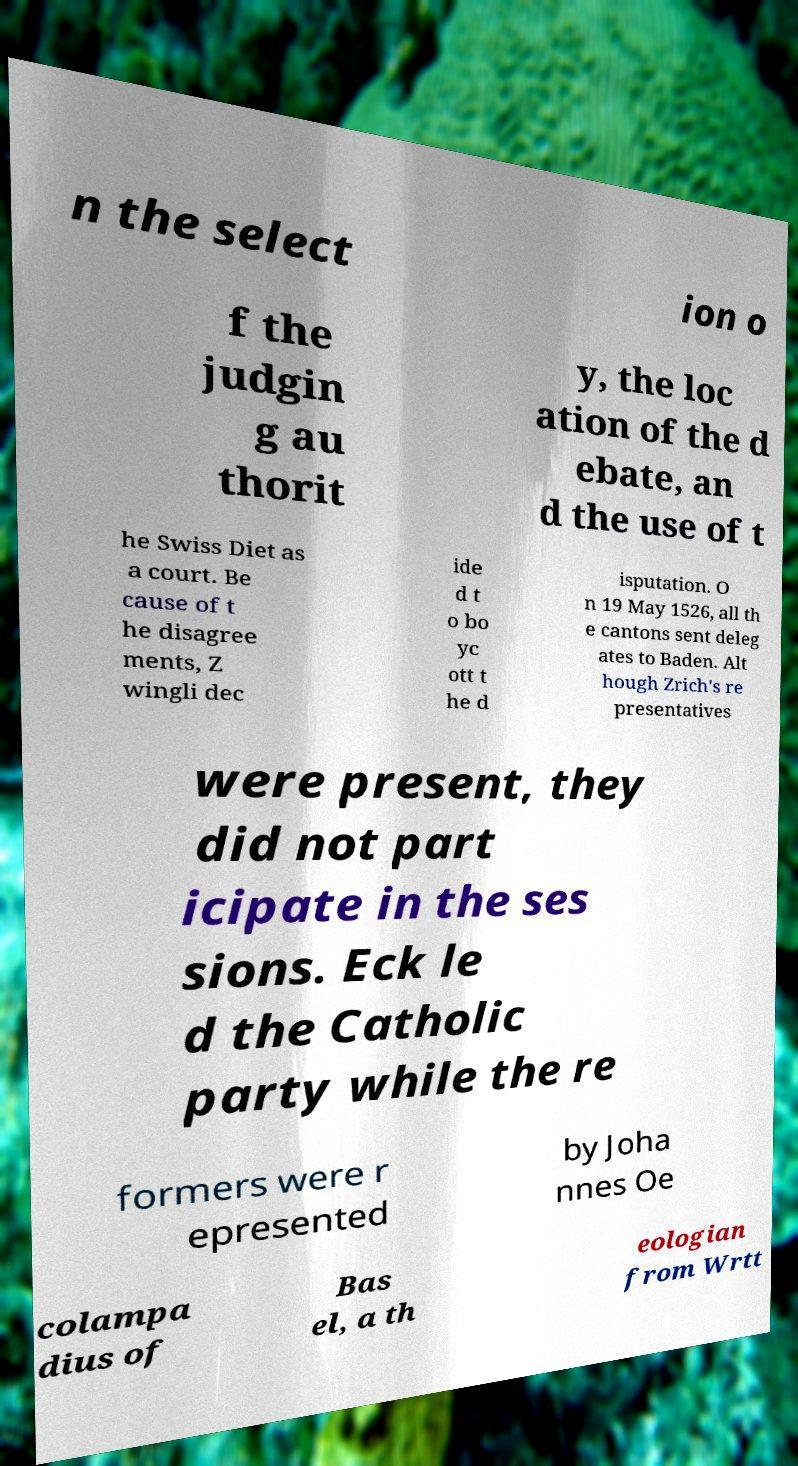There's text embedded in this image that I need extracted. Can you transcribe it verbatim? n the select ion o f the judgin g au thorit y, the loc ation of the d ebate, an d the use of t he Swiss Diet as a court. Be cause of t he disagree ments, Z wingli dec ide d t o bo yc ott t he d isputation. O n 19 May 1526, all th e cantons sent deleg ates to Baden. Alt hough Zrich's re presentatives were present, they did not part icipate in the ses sions. Eck le d the Catholic party while the re formers were r epresented by Joha nnes Oe colampa dius of Bas el, a th eologian from Wrtt 